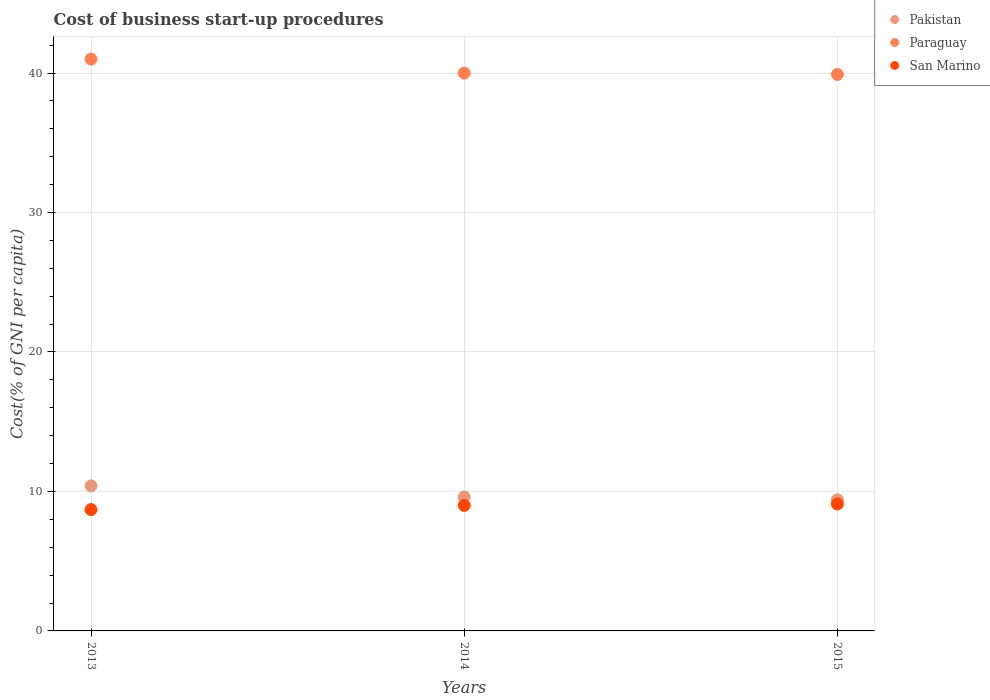In which year was the cost of business start-up procedures in San Marino minimum?
Keep it short and to the point. 2013. What is the total cost of business start-up procedures in San Marino in the graph?
Your answer should be compact. 26.8. What is the difference between the cost of business start-up procedures in Pakistan in 2014 and that in 2015?
Keep it short and to the point. 0.2. What is the difference between the cost of business start-up procedures in Paraguay in 2015 and the cost of business start-up procedures in San Marino in 2014?
Make the answer very short. 30.9. What is the average cost of business start-up procedures in San Marino per year?
Provide a succinct answer. 8.93. In the year 2014, what is the difference between the cost of business start-up procedures in Pakistan and cost of business start-up procedures in San Marino?
Provide a succinct answer. 0.6. What is the ratio of the cost of business start-up procedures in Pakistan in 2014 to that in 2015?
Your response must be concise. 1.02. Is the difference between the cost of business start-up procedures in Pakistan in 2014 and 2015 greater than the difference between the cost of business start-up procedures in San Marino in 2014 and 2015?
Make the answer very short. Yes. What is the difference between the highest and the second highest cost of business start-up procedures in San Marino?
Give a very brief answer. 0.1. What is the difference between the highest and the lowest cost of business start-up procedures in Paraguay?
Keep it short and to the point. 1.1. Is the sum of the cost of business start-up procedures in Paraguay in 2013 and 2015 greater than the maximum cost of business start-up procedures in Pakistan across all years?
Your response must be concise. Yes. Is it the case that in every year, the sum of the cost of business start-up procedures in Paraguay and cost of business start-up procedures in Pakistan  is greater than the cost of business start-up procedures in San Marino?
Keep it short and to the point. Yes. Does the cost of business start-up procedures in Pakistan monotonically increase over the years?
Your answer should be compact. No. Is the cost of business start-up procedures in Pakistan strictly greater than the cost of business start-up procedures in San Marino over the years?
Provide a short and direct response. Yes. Is the cost of business start-up procedures in Pakistan strictly less than the cost of business start-up procedures in San Marino over the years?
Your response must be concise. No. How many years are there in the graph?
Your answer should be compact. 3. What is the difference between two consecutive major ticks on the Y-axis?
Your answer should be compact. 10. Are the values on the major ticks of Y-axis written in scientific E-notation?
Provide a succinct answer. No. Does the graph contain grids?
Offer a very short reply. Yes. How many legend labels are there?
Offer a terse response. 3. What is the title of the graph?
Your response must be concise. Cost of business start-up procedures. What is the label or title of the Y-axis?
Keep it short and to the point. Cost(% of GNI per capita). What is the Cost(% of GNI per capita) of Pakistan in 2013?
Make the answer very short. 10.4. What is the Cost(% of GNI per capita) in Paraguay in 2013?
Your answer should be very brief. 41. What is the Cost(% of GNI per capita) of San Marino in 2013?
Your answer should be compact. 8.7. What is the Cost(% of GNI per capita) of Paraguay in 2014?
Make the answer very short. 40. What is the Cost(% of GNI per capita) in Pakistan in 2015?
Your response must be concise. 9.4. What is the Cost(% of GNI per capita) of Paraguay in 2015?
Give a very brief answer. 39.9. What is the Cost(% of GNI per capita) of San Marino in 2015?
Give a very brief answer. 9.1. Across all years, what is the maximum Cost(% of GNI per capita) in Pakistan?
Your answer should be compact. 10.4. Across all years, what is the maximum Cost(% of GNI per capita) of Paraguay?
Ensure brevity in your answer.  41. Across all years, what is the minimum Cost(% of GNI per capita) of Paraguay?
Your answer should be very brief. 39.9. Across all years, what is the minimum Cost(% of GNI per capita) of San Marino?
Ensure brevity in your answer.  8.7. What is the total Cost(% of GNI per capita) of Pakistan in the graph?
Your response must be concise. 29.4. What is the total Cost(% of GNI per capita) in Paraguay in the graph?
Offer a very short reply. 120.9. What is the total Cost(% of GNI per capita) of San Marino in the graph?
Ensure brevity in your answer.  26.8. What is the difference between the Cost(% of GNI per capita) of Pakistan in 2013 and that in 2014?
Make the answer very short. 0.8. What is the difference between the Cost(% of GNI per capita) in Paraguay in 2013 and that in 2014?
Give a very brief answer. 1. What is the difference between the Cost(% of GNI per capita) of Pakistan in 2013 and that in 2015?
Keep it short and to the point. 1. What is the difference between the Cost(% of GNI per capita) of Paraguay in 2013 and that in 2015?
Your answer should be very brief. 1.1. What is the difference between the Cost(% of GNI per capita) of San Marino in 2013 and that in 2015?
Give a very brief answer. -0.4. What is the difference between the Cost(% of GNI per capita) of San Marino in 2014 and that in 2015?
Offer a very short reply. -0.1. What is the difference between the Cost(% of GNI per capita) in Pakistan in 2013 and the Cost(% of GNI per capita) in Paraguay in 2014?
Make the answer very short. -29.6. What is the difference between the Cost(% of GNI per capita) in Paraguay in 2013 and the Cost(% of GNI per capita) in San Marino in 2014?
Keep it short and to the point. 32. What is the difference between the Cost(% of GNI per capita) in Pakistan in 2013 and the Cost(% of GNI per capita) in Paraguay in 2015?
Offer a terse response. -29.5. What is the difference between the Cost(% of GNI per capita) of Paraguay in 2013 and the Cost(% of GNI per capita) of San Marino in 2015?
Provide a short and direct response. 31.9. What is the difference between the Cost(% of GNI per capita) in Pakistan in 2014 and the Cost(% of GNI per capita) in Paraguay in 2015?
Ensure brevity in your answer.  -30.3. What is the difference between the Cost(% of GNI per capita) in Pakistan in 2014 and the Cost(% of GNI per capita) in San Marino in 2015?
Provide a short and direct response. 0.5. What is the difference between the Cost(% of GNI per capita) in Paraguay in 2014 and the Cost(% of GNI per capita) in San Marino in 2015?
Keep it short and to the point. 30.9. What is the average Cost(% of GNI per capita) in Pakistan per year?
Ensure brevity in your answer.  9.8. What is the average Cost(% of GNI per capita) in Paraguay per year?
Ensure brevity in your answer.  40.3. What is the average Cost(% of GNI per capita) of San Marino per year?
Your answer should be compact. 8.93. In the year 2013, what is the difference between the Cost(% of GNI per capita) of Pakistan and Cost(% of GNI per capita) of Paraguay?
Provide a short and direct response. -30.6. In the year 2013, what is the difference between the Cost(% of GNI per capita) in Pakistan and Cost(% of GNI per capita) in San Marino?
Provide a short and direct response. 1.7. In the year 2013, what is the difference between the Cost(% of GNI per capita) of Paraguay and Cost(% of GNI per capita) of San Marino?
Keep it short and to the point. 32.3. In the year 2014, what is the difference between the Cost(% of GNI per capita) of Pakistan and Cost(% of GNI per capita) of Paraguay?
Ensure brevity in your answer.  -30.4. In the year 2014, what is the difference between the Cost(% of GNI per capita) of Paraguay and Cost(% of GNI per capita) of San Marino?
Your response must be concise. 31. In the year 2015, what is the difference between the Cost(% of GNI per capita) of Pakistan and Cost(% of GNI per capita) of Paraguay?
Offer a very short reply. -30.5. In the year 2015, what is the difference between the Cost(% of GNI per capita) in Pakistan and Cost(% of GNI per capita) in San Marino?
Your answer should be very brief. 0.3. In the year 2015, what is the difference between the Cost(% of GNI per capita) of Paraguay and Cost(% of GNI per capita) of San Marino?
Your response must be concise. 30.8. What is the ratio of the Cost(% of GNI per capita) of Pakistan in 2013 to that in 2014?
Offer a very short reply. 1.08. What is the ratio of the Cost(% of GNI per capita) of San Marino in 2013 to that in 2014?
Give a very brief answer. 0.97. What is the ratio of the Cost(% of GNI per capita) in Pakistan in 2013 to that in 2015?
Your answer should be compact. 1.11. What is the ratio of the Cost(% of GNI per capita) in Paraguay in 2013 to that in 2015?
Offer a very short reply. 1.03. What is the ratio of the Cost(% of GNI per capita) of San Marino in 2013 to that in 2015?
Ensure brevity in your answer.  0.96. What is the ratio of the Cost(% of GNI per capita) in Pakistan in 2014 to that in 2015?
Your answer should be compact. 1.02. What is the difference between the highest and the second highest Cost(% of GNI per capita) of Paraguay?
Make the answer very short. 1. What is the difference between the highest and the lowest Cost(% of GNI per capita) of San Marino?
Provide a short and direct response. 0.4. 